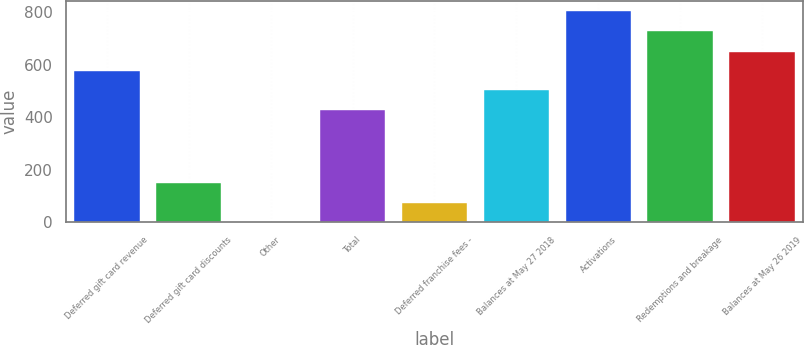<chart> <loc_0><loc_0><loc_500><loc_500><bar_chart><fcel>Deferred gift card revenue<fcel>Deferred gift card discounts<fcel>Other<fcel>Total<fcel>Deferred franchise fees -<fcel>Balances at May 27 2018<fcel>Activations<fcel>Redemptions and breakage<fcel>Balances at May 26 2019<nl><fcel>576.28<fcel>149.08<fcel>1.3<fcel>428.5<fcel>75.19<fcel>502.39<fcel>803.59<fcel>729.7<fcel>650.17<nl></chart> 